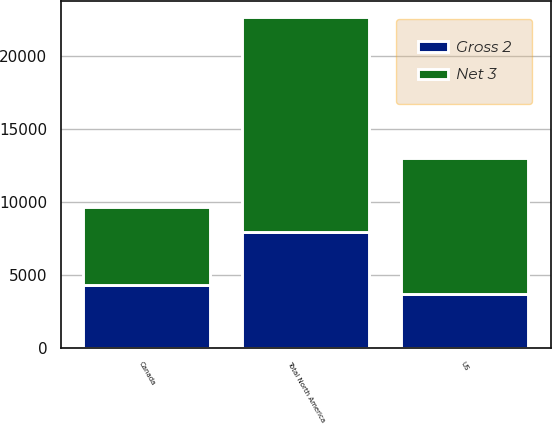Convert chart. <chart><loc_0><loc_0><loc_500><loc_500><stacked_bar_chart><ecel><fcel>US<fcel>Canada<fcel>Total North America<nl><fcel>Net 3<fcel>9328<fcel>5416<fcel>14744<nl><fcel>Gross 2<fcel>3669<fcel>4271<fcel>7940<nl></chart> 